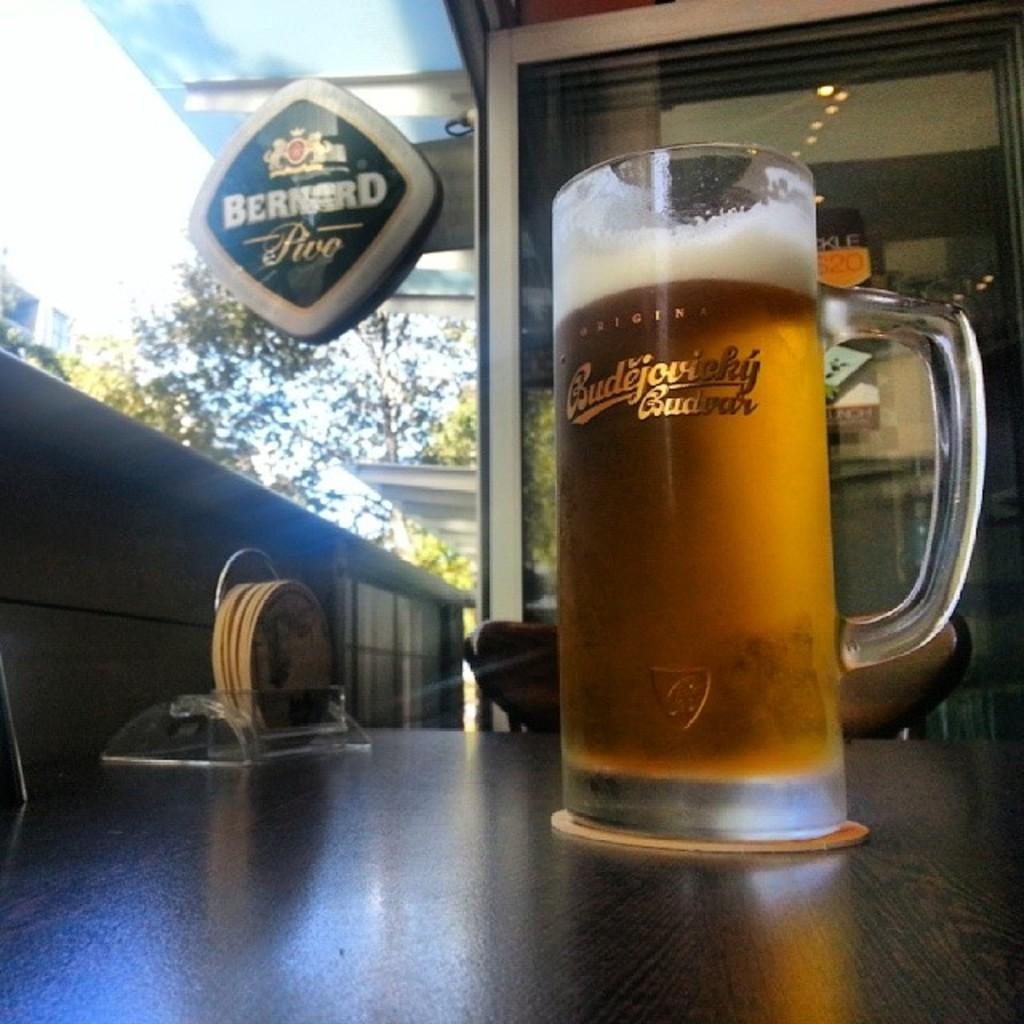<image>
Describe the image concisely. A glass labeled Budejovieky Budwar is filled with beer. 